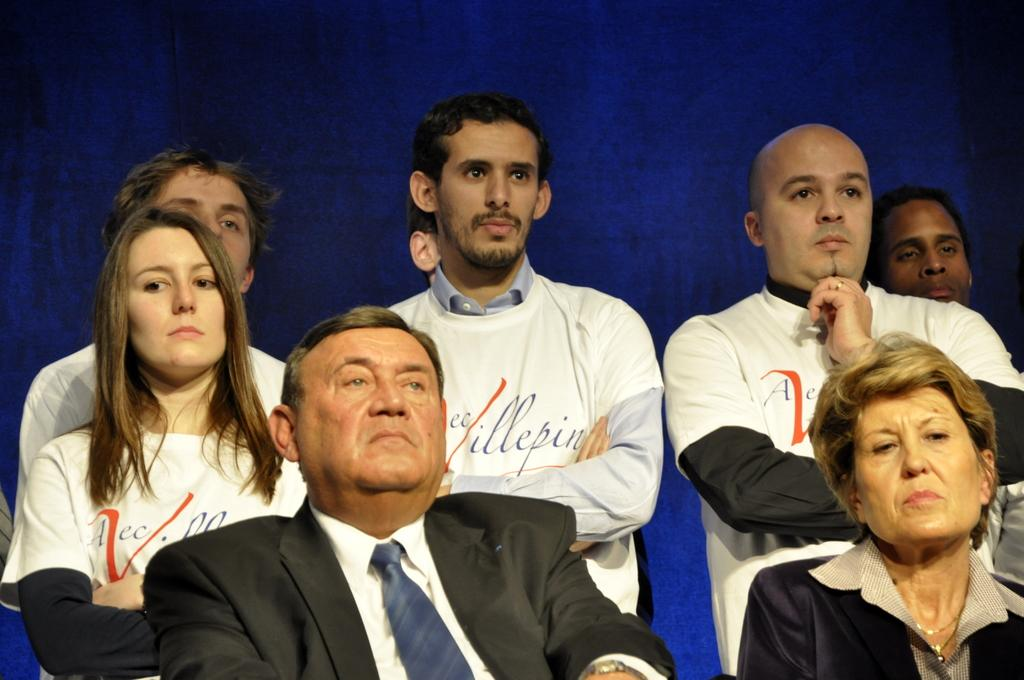How many people are in the image? There are people in the image, but the exact number is not specified. What are some of the people doing in the image? Some people are sitting, and some people are standing. What color is the background in the image? The background in the image is blue. How many cats can be seen in the image? There are no cats present in the image. What type of cellar is visible in the image? There is no cellar present in the image. 